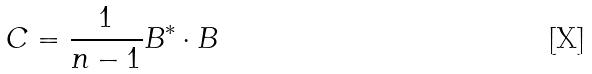<formula> <loc_0><loc_0><loc_500><loc_500>C = \frac { 1 } { n - 1 } B ^ { * } \cdot B</formula> 